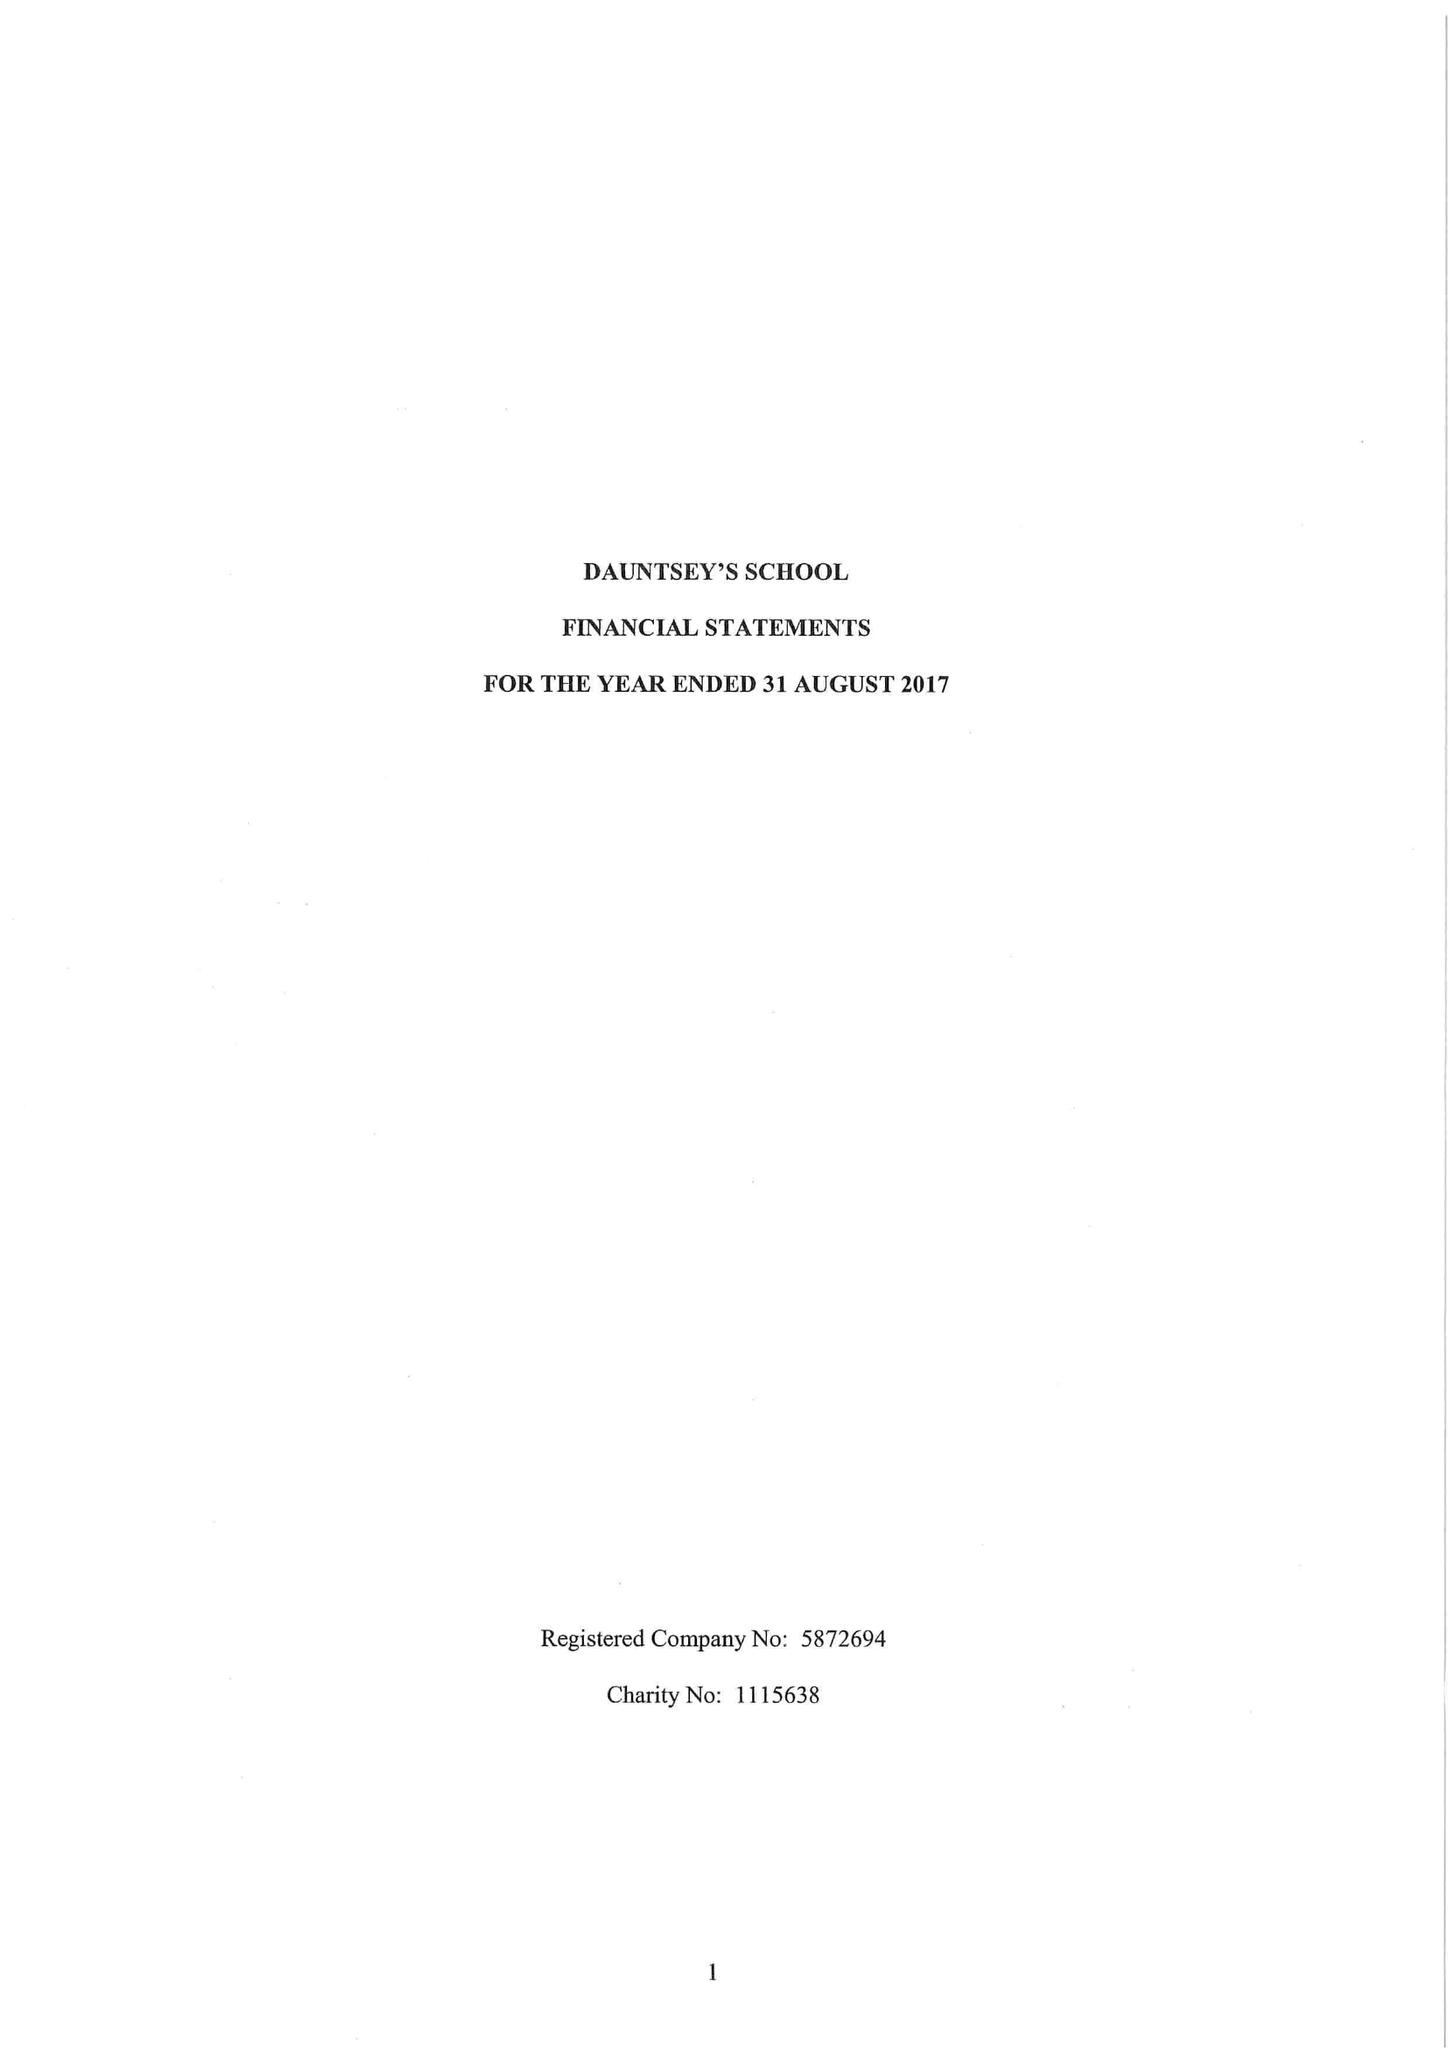What is the value for the report_date?
Answer the question using a single word or phrase. 2017-08-31 